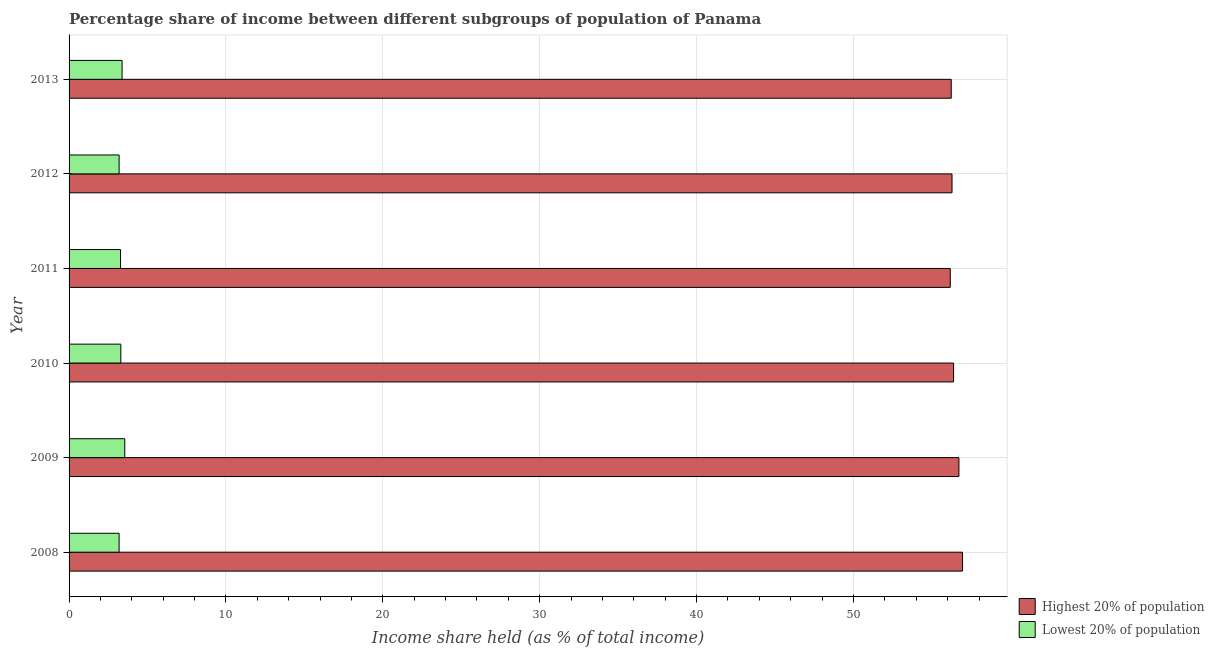How many different coloured bars are there?
Offer a terse response. 2. Are the number of bars on each tick of the Y-axis equal?
Make the answer very short. Yes. How many bars are there on the 2nd tick from the top?
Ensure brevity in your answer.  2. How many bars are there on the 6th tick from the bottom?
Provide a short and direct response. 2. What is the label of the 4th group of bars from the top?
Your response must be concise. 2010. In how many cases, is the number of bars for a given year not equal to the number of legend labels?
Offer a terse response. 0. What is the income share held by lowest 20% of the population in 2010?
Keep it short and to the point. 3.3. Across all years, what is the maximum income share held by lowest 20% of the population?
Give a very brief answer. 3.55. Across all years, what is the minimum income share held by highest 20% of the population?
Provide a short and direct response. 56.17. In which year was the income share held by lowest 20% of the population maximum?
Offer a terse response. 2009. What is the total income share held by lowest 20% of the population in the graph?
Your answer should be compact. 19.89. What is the difference between the income share held by highest 20% of the population in 2009 and that in 2012?
Keep it short and to the point. 0.44. What is the difference between the income share held by highest 20% of the population in 2008 and the income share held by lowest 20% of the population in 2011?
Offer a terse response. 53.67. What is the average income share held by highest 20% of the population per year?
Your answer should be compact. 56.45. In the year 2009, what is the difference between the income share held by lowest 20% of the population and income share held by highest 20% of the population?
Ensure brevity in your answer.  -53.17. In how many years, is the income share held by highest 20% of the population greater than 38 %?
Offer a very short reply. 6. What is the ratio of the income share held by lowest 20% of the population in 2010 to that in 2013?
Keep it short and to the point. 0.98. Is the income share held by highest 20% of the population in 2010 less than that in 2013?
Give a very brief answer. No. Is the difference between the income share held by highest 20% of the population in 2008 and 2010 greater than the difference between the income share held by lowest 20% of the population in 2008 and 2010?
Offer a very short reply. Yes. What is the difference between the highest and the second highest income share held by highest 20% of the population?
Your response must be concise. 0.23. What is the difference between the highest and the lowest income share held by lowest 20% of the population?
Your answer should be very brief. 0.36. What does the 2nd bar from the top in 2011 represents?
Provide a short and direct response. Highest 20% of population. What does the 1st bar from the bottom in 2010 represents?
Ensure brevity in your answer.  Highest 20% of population. How many bars are there?
Keep it short and to the point. 12. Are all the bars in the graph horizontal?
Your answer should be very brief. Yes. What is the difference between two consecutive major ticks on the X-axis?
Provide a succinct answer. 10. Does the graph contain any zero values?
Your answer should be very brief. No. Does the graph contain grids?
Your answer should be very brief. Yes. How many legend labels are there?
Ensure brevity in your answer.  2. What is the title of the graph?
Make the answer very short. Percentage share of income between different subgroups of population of Panama. Does "Lowest 20% of population" appear as one of the legend labels in the graph?
Provide a short and direct response. Yes. What is the label or title of the X-axis?
Offer a very short reply. Income share held (as % of total income). What is the label or title of the Y-axis?
Offer a very short reply. Year. What is the Income share held (as % of total income) in Highest 20% of population in 2008?
Ensure brevity in your answer.  56.95. What is the Income share held (as % of total income) of Lowest 20% of population in 2008?
Provide a succinct answer. 3.19. What is the Income share held (as % of total income) in Highest 20% of population in 2009?
Offer a very short reply. 56.72. What is the Income share held (as % of total income) in Lowest 20% of population in 2009?
Your answer should be compact. 3.55. What is the Income share held (as % of total income) of Highest 20% of population in 2010?
Provide a short and direct response. 56.38. What is the Income share held (as % of total income) in Highest 20% of population in 2011?
Offer a very short reply. 56.17. What is the Income share held (as % of total income) in Lowest 20% of population in 2011?
Your response must be concise. 3.28. What is the Income share held (as % of total income) in Highest 20% of population in 2012?
Offer a very short reply. 56.28. What is the Income share held (as % of total income) of Lowest 20% of population in 2012?
Offer a very short reply. 3.19. What is the Income share held (as % of total income) of Highest 20% of population in 2013?
Keep it short and to the point. 56.23. What is the Income share held (as % of total income) of Lowest 20% of population in 2013?
Offer a very short reply. 3.38. Across all years, what is the maximum Income share held (as % of total income) in Highest 20% of population?
Your answer should be very brief. 56.95. Across all years, what is the maximum Income share held (as % of total income) of Lowest 20% of population?
Your answer should be compact. 3.55. Across all years, what is the minimum Income share held (as % of total income) in Highest 20% of population?
Your answer should be compact. 56.17. Across all years, what is the minimum Income share held (as % of total income) of Lowest 20% of population?
Give a very brief answer. 3.19. What is the total Income share held (as % of total income) in Highest 20% of population in the graph?
Your answer should be very brief. 338.73. What is the total Income share held (as % of total income) of Lowest 20% of population in the graph?
Provide a succinct answer. 19.89. What is the difference between the Income share held (as % of total income) in Highest 20% of population in 2008 and that in 2009?
Your response must be concise. 0.23. What is the difference between the Income share held (as % of total income) in Lowest 20% of population in 2008 and that in 2009?
Keep it short and to the point. -0.36. What is the difference between the Income share held (as % of total income) of Highest 20% of population in 2008 and that in 2010?
Make the answer very short. 0.57. What is the difference between the Income share held (as % of total income) of Lowest 20% of population in 2008 and that in 2010?
Provide a short and direct response. -0.11. What is the difference between the Income share held (as % of total income) of Highest 20% of population in 2008 and that in 2011?
Make the answer very short. 0.78. What is the difference between the Income share held (as % of total income) in Lowest 20% of population in 2008 and that in 2011?
Offer a very short reply. -0.09. What is the difference between the Income share held (as % of total income) in Highest 20% of population in 2008 and that in 2012?
Your answer should be very brief. 0.67. What is the difference between the Income share held (as % of total income) of Lowest 20% of population in 2008 and that in 2012?
Make the answer very short. 0. What is the difference between the Income share held (as % of total income) in Highest 20% of population in 2008 and that in 2013?
Ensure brevity in your answer.  0.72. What is the difference between the Income share held (as % of total income) of Lowest 20% of population in 2008 and that in 2013?
Provide a succinct answer. -0.19. What is the difference between the Income share held (as % of total income) of Highest 20% of population in 2009 and that in 2010?
Offer a very short reply. 0.34. What is the difference between the Income share held (as % of total income) in Highest 20% of population in 2009 and that in 2011?
Your response must be concise. 0.55. What is the difference between the Income share held (as % of total income) in Lowest 20% of population in 2009 and that in 2011?
Your response must be concise. 0.27. What is the difference between the Income share held (as % of total income) in Highest 20% of population in 2009 and that in 2012?
Your answer should be very brief. 0.44. What is the difference between the Income share held (as % of total income) in Lowest 20% of population in 2009 and that in 2012?
Offer a terse response. 0.36. What is the difference between the Income share held (as % of total income) of Highest 20% of population in 2009 and that in 2013?
Your answer should be compact. 0.49. What is the difference between the Income share held (as % of total income) in Lowest 20% of population in 2009 and that in 2013?
Your response must be concise. 0.17. What is the difference between the Income share held (as % of total income) in Highest 20% of population in 2010 and that in 2011?
Your response must be concise. 0.21. What is the difference between the Income share held (as % of total income) in Lowest 20% of population in 2010 and that in 2012?
Make the answer very short. 0.11. What is the difference between the Income share held (as % of total income) of Highest 20% of population in 2010 and that in 2013?
Provide a short and direct response. 0.15. What is the difference between the Income share held (as % of total income) of Lowest 20% of population in 2010 and that in 2013?
Give a very brief answer. -0.08. What is the difference between the Income share held (as % of total income) of Highest 20% of population in 2011 and that in 2012?
Make the answer very short. -0.11. What is the difference between the Income share held (as % of total income) in Lowest 20% of population in 2011 and that in 2012?
Ensure brevity in your answer.  0.09. What is the difference between the Income share held (as % of total income) of Highest 20% of population in 2011 and that in 2013?
Give a very brief answer. -0.06. What is the difference between the Income share held (as % of total income) of Highest 20% of population in 2012 and that in 2013?
Your answer should be compact. 0.05. What is the difference between the Income share held (as % of total income) in Lowest 20% of population in 2012 and that in 2013?
Your answer should be compact. -0.19. What is the difference between the Income share held (as % of total income) of Highest 20% of population in 2008 and the Income share held (as % of total income) of Lowest 20% of population in 2009?
Your response must be concise. 53.4. What is the difference between the Income share held (as % of total income) in Highest 20% of population in 2008 and the Income share held (as % of total income) in Lowest 20% of population in 2010?
Give a very brief answer. 53.65. What is the difference between the Income share held (as % of total income) in Highest 20% of population in 2008 and the Income share held (as % of total income) in Lowest 20% of population in 2011?
Ensure brevity in your answer.  53.67. What is the difference between the Income share held (as % of total income) in Highest 20% of population in 2008 and the Income share held (as % of total income) in Lowest 20% of population in 2012?
Offer a very short reply. 53.76. What is the difference between the Income share held (as % of total income) in Highest 20% of population in 2008 and the Income share held (as % of total income) in Lowest 20% of population in 2013?
Keep it short and to the point. 53.57. What is the difference between the Income share held (as % of total income) in Highest 20% of population in 2009 and the Income share held (as % of total income) in Lowest 20% of population in 2010?
Give a very brief answer. 53.42. What is the difference between the Income share held (as % of total income) of Highest 20% of population in 2009 and the Income share held (as % of total income) of Lowest 20% of population in 2011?
Make the answer very short. 53.44. What is the difference between the Income share held (as % of total income) in Highest 20% of population in 2009 and the Income share held (as % of total income) in Lowest 20% of population in 2012?
Give a very brief answer. 53.53. What is the difference between the Income share held (as % of total income) in Highest 20% of population in 2009 and the Income share held (as % of total income) in Lowest 20% of population in 2013?
Make the answer very short. 53.34. What is the difference between the Income share held (as % of total income) of Highest 20% of population in 2010 and the Income share held (as % of total income) of Lowest 20% of population in 2011?
Your answer should be compact. 53.1. What is the difference between the Income share held (as % of total income) in Highest 20% of population in 2010 and the Income share held (as % of total income) in Lowest 20% of population in 2012?
Keep it short and to the point. 53.19. What is the difference between the Income share held (as % of total income) of Highest 20% of population in 2010 and the Income share held (as % of total income) of Lowest 20% of population in 2013?
Your answer should be very brief. 53. What is the difference between the Income share held (as % of total income) of Highest 20% of population in 2011 and the Income share held (as % of total income) of Lowest 20% of population in 2012?
Your response must be concise. 52.98. What is the difference between the Income share held (as % of total income) in Highest 20% of population in 2011 and the Income share held (as % of total income) in Lowest 20% of population in 2013?
Your answer should be very brief. 52.79. What is the difference between the Income share held (as % of total income) in Highest 20% of population in 2012 and the Income share held (as % of total income) in Lowest 20% of population in 2013?
Ensure brevity in your answer.  52.9. What is the average Income share held (as % of total income) of Highest 20% of population per year?
Provide a short and direct response. 56.45. What is the average Income share held (as % of total income) of Lowest 20% of population per year?
Ensure brevity in your answer.  3.31. In the year 2008, what is the difference between the Income share held (as % of total income) in Highest 20% of population and Income share held (as % of total income) in Lowest 20% of population?
Your response must be concise. 53.76. In the year 2009, what is the difference between the Income share held (as % of total income) of Highest 20% of population and Income share held (as % of total income) of Lowest 20% of population?
Keep it short and to the point. 53.17. In the year 2010, what is the difference between the Income share held (as % of total income) of Highest 20% of population and Income share held (as % of total income) of Lowest 20% of population?
Make the answer very short. 53.08. In the year 2011, what is the difference between the Income share held (as % of total income) in Highest 20% of population and Income share held (as % of total income) in Lowest 20% of population?
Ensure brevity in your answer.  52.89. In the year 2012, what is the difference between the Income share held (as % of total income) in Highest 20% of population and Income share held (as % of total income) in Lowest 20% of population?
Ensure brevity in your answer.  53.09. In the year 2013, what is the difference between the Income share held (as % of total income) of Highest 20% of population and Income share held (as % of total income) of Lowest 20% of population?
Your answer should be very brief. 52.85. What is the ratio of the Income share held (as % of total income) of Highest 20% of population in 2008 to that in 2009?
Your answer should be very brief. 1. What is the ratio of the Income share held (as % of total income) in Lowest 20% of population in 2008 to that in 2009?
Make the answer very short. 0.9. What is the ratio of the Income share held (as % of total income) of Highest 20% of population in 2008 to that in 2010?
Your answer should be very brief. 1.01. What is the ratio of the Income share held (as % of total income) of Lowest 20% of population in 2008 to that in 2010?
Provide a succinct answer. 0.97. What is the ratio of the Income share held (as % of total income) of Highest 20% of population in 2008 to that in 2011?
Your response must be concise. 1.01. What is the ratio of the Income share held (as % of total income) in Lowest 20% of population in 2008 to that in 2011?
Your response must be concise. 0.97. What is the ratio of the Income share held (as % of total income) in Highest 20% of population in 2008 to that in 2012?
Ensure brevity in your answer.  1.01. What is the ratio of the Income share held (as % of total income) of Highest 20% of population in 2008 to that in 2013?
Ensure brevity in your answer.  1.01. What is the ratio of the Income share held (as % of total income) in Lowest 20% of population in 2008 to that in 2013?
Make the answer very short. 0.94. What is the ratio of the Income share held (as % of total income) of Lowest 20% of population in 2009 to that in 2010?
Ensure brevity in your answer.  1.08. What is the ratio of the Income share held (as % of total income) of Highest 20% of population in 2009 to that in 2011?
Offer a very short reply. 1.01. What is the ratio of the Income share held (as % of total income) of Lowest 20% of population in 2009 to that in 2011?
Your answer should be very brief. 1.08. What is the ratio of the Income share held (as % of total income) in Highest 20% of population in 2009 to that in 2012?
Your answer should be very brief. 1.01. What is the ratio of the Income share held (as % of total income) of Lowest 20% of population in 2009 to that in 2012?
Your answer should be very brief. 1.11. What is the ratio of the Income share held (as % of total income) of Highest 20% of population in 2009 to that in 2013?
Offer a terse response. 1.01. What is the ratio of the Income share held (as % of total income) of Lowest 20% of population in 2009 to that in 2013?
Keep it short and to the point. 1.05. What is the ratio of the Income share held (as % of total income) of Lowest 20% of population in 2010 to that in 2011?
Your answer should be very brief. 1.01. What is the ratio of the Income share held (as % of total income) in Highest 20% of population in 2010 to that in 2012?
Ensure brevity in your answer.  1. What is the ratio of the Income share held (as % of total income) of Lowest 20% of population in 2010 to that in 2012?
Ensure brevity in your answer.  1.03. What is the ratio of the Income share held (as % of total income) in Lowest 20% of population in 2010 to that in 2013?
Your answer should be very brief. 0.98. What is the ratio of the Income share held (as % of total income) in Lowest 20% of population in 2011 to that in 2012?
Provide a succinct answer. 1.03. What is the ratio of the Income share held (as % of total income) in Lowest 20% of population in 2011 to that in 2013?
Give a very brief answer. 0.97. What is the ratio of the Income share held (as % of total income) of Highest 20% of population in 2012 to that in 2013?
Provide a short and direct response. 1. What is the ratio of the Income share held (as % of total income) of Lowest 20% of population in 2012 to that in 2013?
Keep it short and to the point. 0.94. What is the difference between the highest and the second highest Income share held (as % of total income) of Highest 20% of population?
Offer a terse response. 0.23. What is the difference between the highest and the second highest Income share held (as % of total income) of Lowest 20% of population?
Your answer should be very brief. 0.17. What is the difference between the highest and the lowest Income share held (as % of total income) of Highest 20% of population?
Your response must be concise. 0.78. What is the difference between the highest and the lowest Income share held (as % of total income) of Lowest 20% of population?
Give a very brief answer. 0.36. 